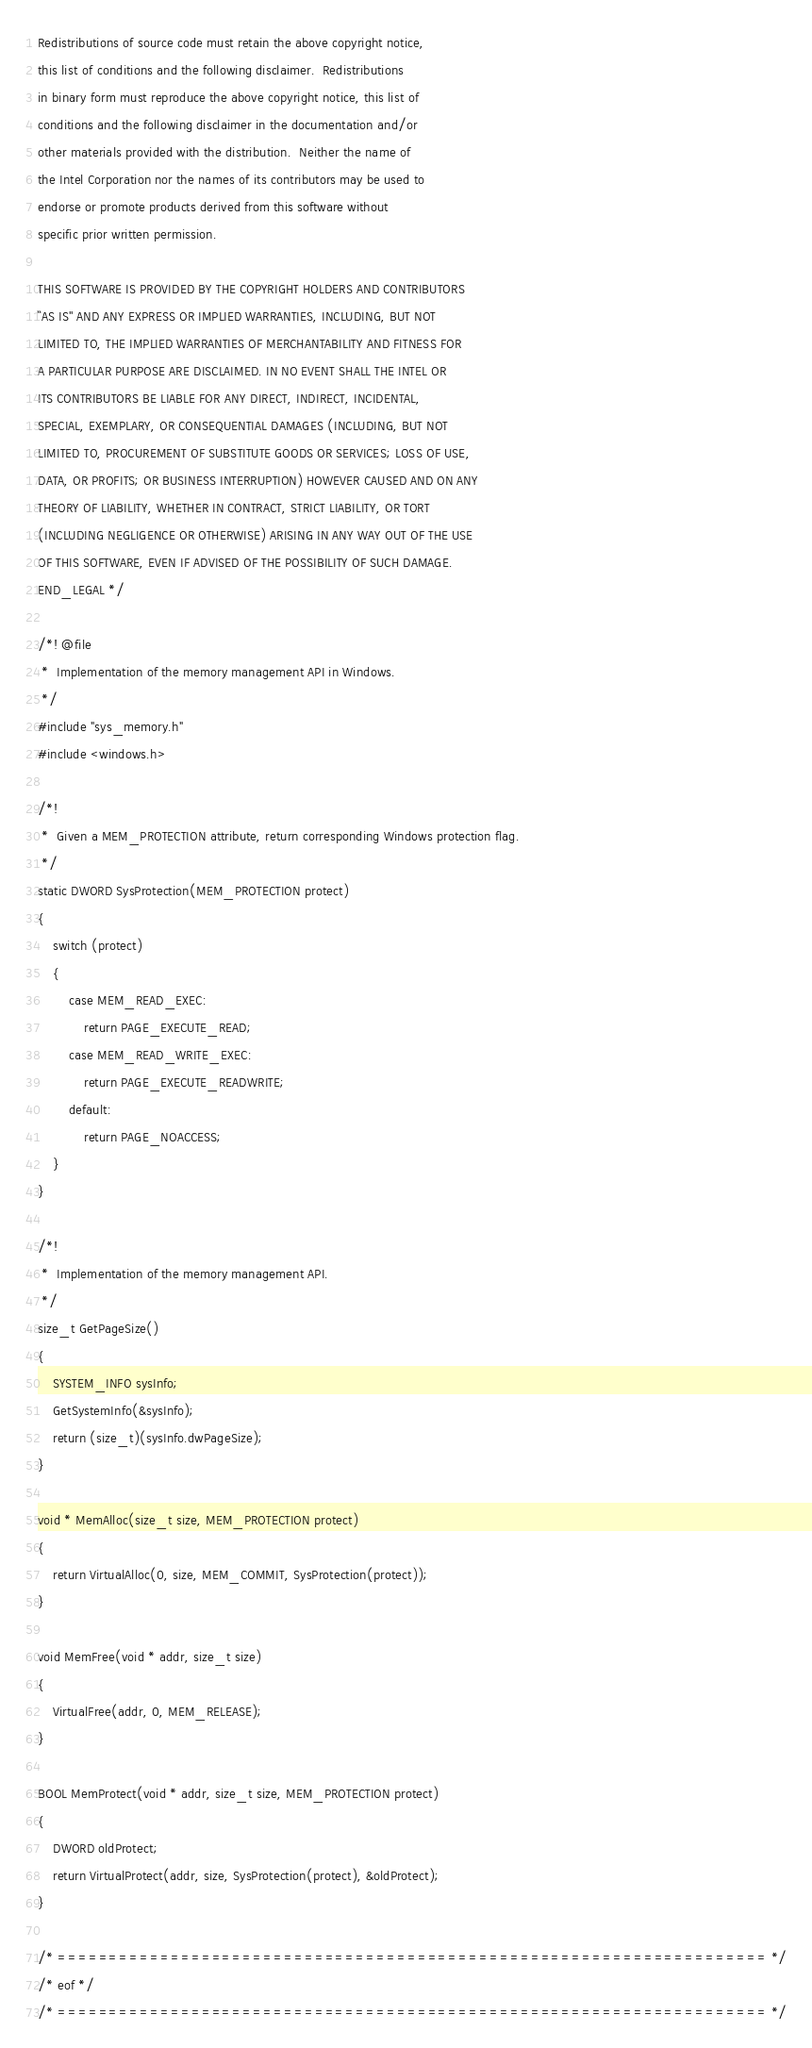Convert code to text. <code><loc_0><loc_0><loc_500><loc_500><_C_>
Redistributions of source code must retain the above copyright notice,
this list of conditions and the following disclaimer.  Redistributions
in binary form must reproduce the above copyright notice, this list of
conditions and the following disclaimer in the documentation and/or
other materials provided with the distribution.  Neither the name of
the Intel Corporation nor the names of its contributors may be used to
endorse or promote products derived from this software without
specific prior written permission.
 
THIS SOFTWARE IS PROVIDED BY THE COPYRIGHT HOLDERS AND CONTRIBUTORS
``AS IS'' AND ANY EXPRESS OR IMPLIED WARRANTIES, INCLUDING, BUT NOT
LIMITED TO, THE IMPLIED WARRANTIES OF MERCHANTABILITY AND FITNESS FOR
A PARTICULAR PURPOSE ARE DISCLAIMED. IN NO EVENT SHALL THE INTEL OR
ITS CONTRIBUTORS BE LIABLE FOR ANY DIRECT, INDIRECT, INCIDENTAL,
SPECIAL, EXEMPLARY, OR CONSEQUENTIAL DAMAGES (INCLUDING, BUT NOT
LIMITED TO, PROCUREMENT OF SUBSTITUTE GOODS OR SERVICES; LOSS OF USE,
DATA, OR PROFITS; OR BUSINESS INTERRUPTION) HOWEVER CAUSED AND ON ANY
THEORY OF LIABILITY, WHETHER IN CONTRACT, STRICT LIABILITY, OR TORT
(INCLUDING NEGLIGENCE OR OTHERWISE) ARISING IN ANY WAY OUT OF THE USE
OF THIS SOFTWARE, EVEN IF ADVISED OF THE POSSIBILITY OF SUCH DAMAGE.
END_LEGAL */

/*! @file
 *  Implementation of the memory management API in Windows. 
 */
#include "sys_memory.h"
#include <windows.h>

/*!
 *  Given a MEM_PROTECTION attribute, return corresponding Windows protection flag. 
 */
static DWORD SysProtection(MEM_PROTECTION protect)
{
    switch (protect)
    {
        case MEM_READ_EXEC:
            return PAGE_EXECUTE_READ;
        case MEM_READ_WRITE_EXEC:
            return PAGE_EXECUTE_READWRITE;
        default:
            return PAGE_NOACCESS;
    }
}

/*!
 *  Implementation of the memory management API. 
 */
size_t GetPageSize()
{
    SYSTEM_INFO sysInfo;
    GetSystemInfo(&sysInfo);
    return (size_t)(sysInfo.dwPageSize);
}

void * MemAlloc(size_t size, MEM_PROTECTION protect)
{
    return VirtualAlloc(0, size, MEM_COMMIT, SysProtection(protect));
}

void MemFree(void * addr, size_t size)
{
    VirtualFree(addr, 0, MEM_RELEASE);
}

BOOL MemProtect(void * addr, size_t size, MEM_PROTECTION protect)
{
    DWORD oldProtect;
    return VirtualProtect(addr, size, SysProtection(protect), &oldProtect);
}

/* ===================================================================== */
/* eof */
/* ===================================================================== */
</code> 